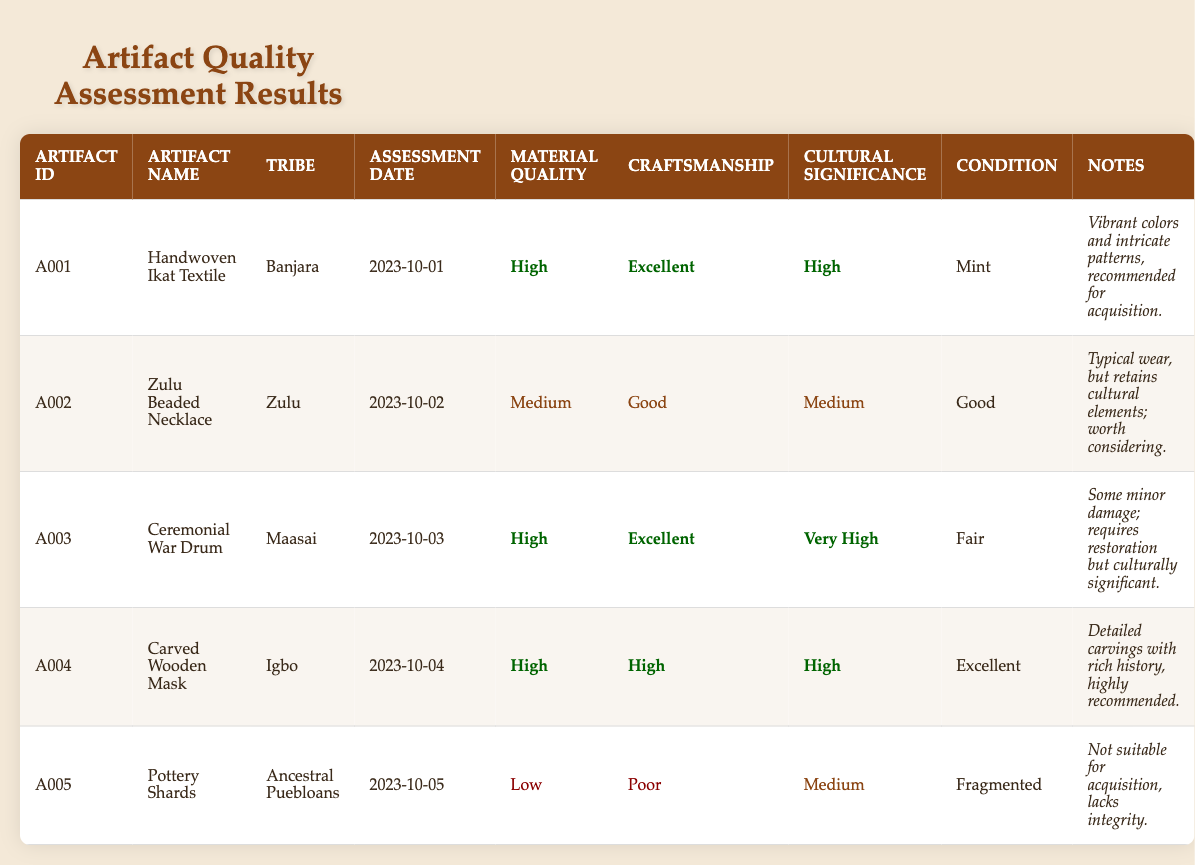What is the cultural significance of the Handwoven Ikat Textile? The table states that the cultural significance of the Handwoven Ikat Textile is classified as "High."
Answer: High Which artifact is in "Mint" condition? The Handwoven Ikat Textile is the only artifact listed with a condition of "Mint."
Answer: Handwoven Ikat Textile How many artifacts have "Excellent" craftsmanship? The Handwoven Ikat Textile, Ceremonial War Drum, and Carved Wooden Mask are the artifacts with "Excellent" craftsmanship. There are 3 such artifacts.
Answer: 3 Is the Zulu Beaded Necklace recommended for acquisition? The notes for the Zulu Beaded Necklace suggest it is worth considering but does not strongly recommend acquisition like others.
Answer: No Which artifact has the highest cultural significance, and what is its condition? The Ceremonial War Drum has the highest cultural significance labeled as "Very High," and its condition listed is "Fair."
Answer: Ceremonial War Drum, Fair What is the average material quality rating for all artifacts? The material quality ratings and their corresponding values are: High (3), Medium (2), and Low (1). To find the average: (3*3 + 2*2 + 1*1)/(3 + 2 + 1) = (9 + 4 + 1)/6 = 14/6 = 2.33. Since ratings are qualitative, the average corresponds to a rating of Medium.
Answer: Medium Are there any artifacts from the Ancestral Puebloans with a fair or better condition? The only artifact from the Ancestral Puebloans is the Pottery Shards which is in "Fragmented" condition, below fair.
Answer: No Which tribe has the highest number of artifacts with high material quality? The Banjara and Igbo tribes each have one artifact classified with high material quality, while the Maasai tribe has one as well. Therefore no tribe has more than one.
Answer: None Is there an artifact that needs restoration and is still culturally significant? The Ceremonial War Drum needs restoration as noted in the table. Additionally, its cultural significance is classified as "Very High," which confirms its cultural value despite needing repair.
Answer: Yes 